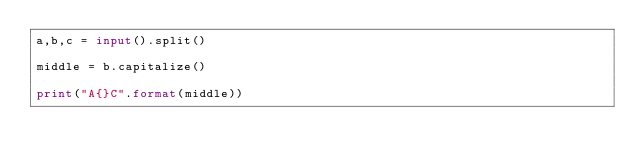Convert code to text. <code><loc_0><loc_0><loc_500><loc_500><_Python_>a,b,c = input().split()

middle = b.capitalize()

print("A{}C".format(middle))</code> 